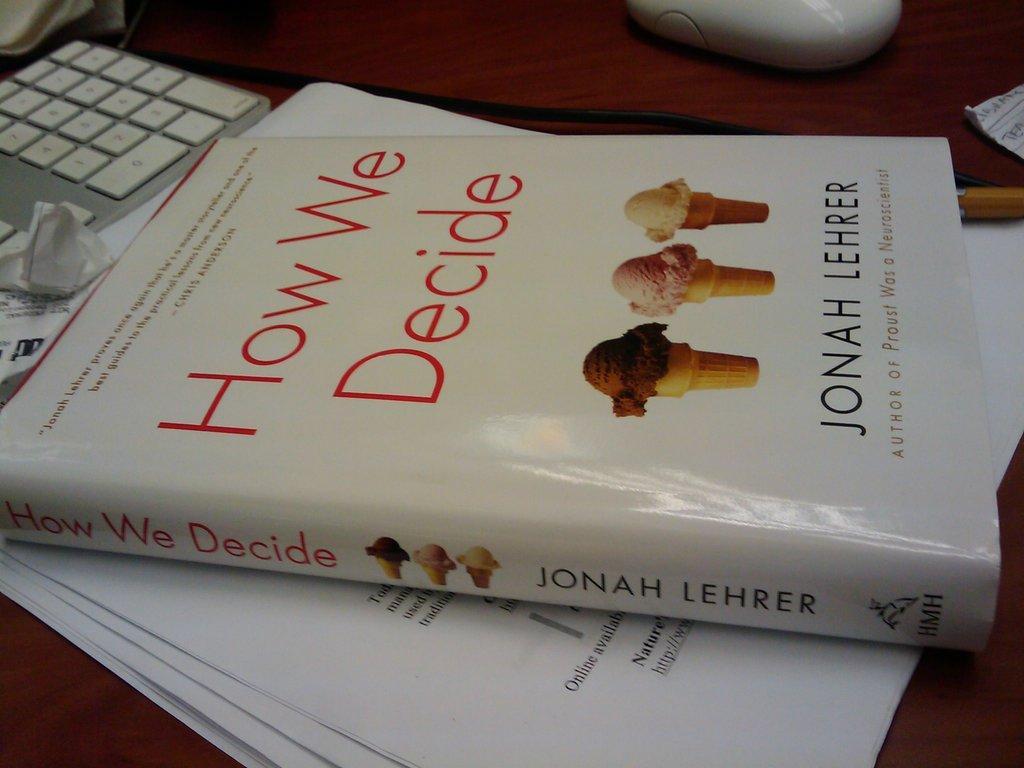Can you describe this image briefly? In this image I can see a book, papers, keyboard, mouse and wire. These are on the brown color table. 